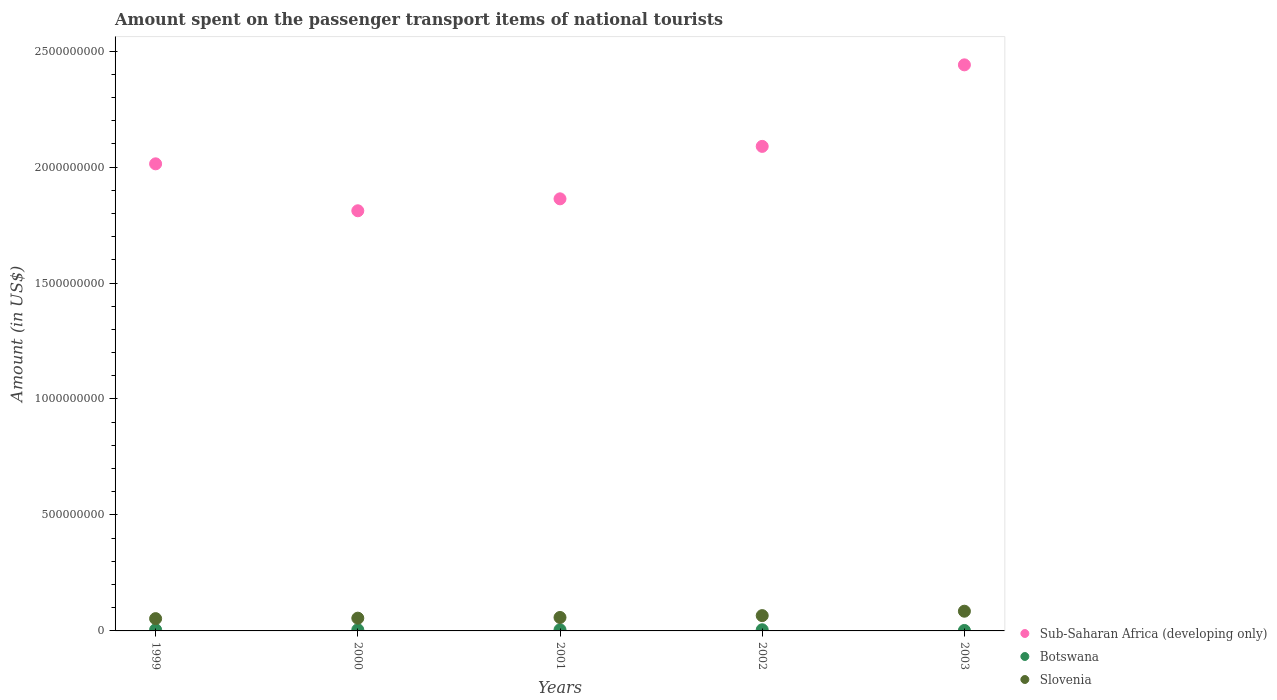How many different coloured dotlines are there?
Offer a terse response. 3. Is the number of dotlines equal to the number of legend labels?
Your response must be concise. Yes. What is the amount spent on the passenger transport items of national tourists in Botswana in 2000?
Make the answer very short. 5.00e+06. Across all years, what is the maximum amount spent on the passenger transport items of national tourists in Botswana?
Your answer should be very brief. 5.00e+06. Across all years, what is the minimum amount spent on the passenger transport items of national tourists in Botswana?
Your response must be concise. 2.00e+06. In which year was the amount spent on the passenger transport items of national tourists in Botswana minimum?
Provide a succinct answer. 2003. What is the total amount spent on the passenger transport items of national tourists in Slovenia in the graph?
Offer a terse response. 3.17e+08. What is the difference between the amount spent on the passenger transport items of national tourists in Sub-Saharan Africa (developing only) in 2000 and that in 2002?
Your answer should be very brief. -2.78e+08. What is the difference between the amount spent on the passenger transport items of national tourists in Botswana in 2003 and the amount spent on the passenger transport items of national tourists in Sub-Saharan Africa (developing only) in 2000?
Make the answer very short. -1.81e+09. What is the average amount spent on the passenger transport items of national tourists in Sub-Saharan Africa (developing only) per year?
Provide a short and direct response. 2.04e+09. In the year 2000, what is the difference between the amount spent on the passenger transport items of national tourists in Slovenia and amount spent on the passenger transport items of national tourists in Sub-Saharan Africa (developing only)?
Provide a succinct answer. -1.76e+09. What is the ratio of the amount spent on the passenger transport items of national tourists in Sub-Saharan Africa (developing only) in 2001 to that in 2002?
Your answer should be very brief. 0.89. Is the difference between the amount spent on the passenger transport items of national tourists in Slovenia in 2000 and 2002 greater than the difference between the amount spent on the passenger transport items of national tourists in Sub-Saharan Africa (developing only) in 2000 and 2002?
Your answer should be very brief. Yes. What is the difference between the highest and the second highest amount spent on the passenger transport items of national tourists in Sub-Saharan Africa (developing only)?
Offer a very short reply. 3.52e+08. What is the difference between the highest and the lowest amount spent on the passenger transport items of national tourists in Sub-Saharan Africa (developing only)?
Provide a short and direct response. 6.29e+08. In how many years, is the amount spent on the passenger transport items of national tourists in Slovenia greater than the average amount spent on the passenger transport items of national tourists in Slovenia taken over all years?
Offer a terse response. 2. Is the sum of the amount spent on the passenger transport items of national tourists in Sub-Saharan Africa (developing only) in 2000 and 2002 greater than the maximum amount spent on the passenger transport items of national tourists in Botswana across all years?
Provide a short and direct response. Yes. Is the amount spent on the passenger transport items of national tourists in Botswana strictly less than the amount spent on the passenger transport items of national tourists in Sub-Saharan Africa (developing only) over the years?
Your answer should be very brief. Yes. Are the values on the major ticks of Y-axis written in scientific E-notation?
Ensure brevity in your answer.  No. Does the graph contain any zero values?
Ensure brevity in your answer.  No. Where does the legend appear in the graph?
Offer a very short reply. Bottom right. How many legend labels are there?
Make the answer very short. 3. How are the legend labels stacked?
Your answer should be very brief. Vertical. What is the title of the graph?
Provide a short and direct response. Amount spent on the passenger transport items of national tourists. What is the label or title of the Y-axis?
Offer a very short reply. Amount (in US$). What is the Amount (in US$) in Sub-Saharan Africa (developing only) in 1999?
Give a very brief answer. 2.01e+09. What is the Amount (in US$) of Botswana in 1999?
Offer a very short reply. 5.00e+06. What is the Amount (in US$) of Slovenia in 1999?
Your answer should be very brief. 5.30e+07. What is the Amount (in US$) in Sub-Saharan Africa (developing only) in 2000?
Your answer should be very brief. 1.81e+09. What is the Amount (in US$) of Botswana in 2000?
Make the answer very short. 5.00e+06. What is the Amount (in US$) in Slovenia in 2000?
Your answer should be very brief. 5.50e+07. What is the Amount (in US$) of Sub-Saharan Africa (developing only) in 2001?
Offer a terse response. 1.86e+09. What is the Amount (in US$) of Slovenia in 2001?
Your answer should be very brief. 5.80e+07. What is the Amount (in US$) in Sub-Saharan Africa (developing only) in 2002?
Make the answer very short. 2.09e+09. What is the Amount (in US$) of Slovenia in 2002?
Keep it short and to the point. 6.60e+07. What is the Amount (in US$) in Sub-Saharan Africa (developing only) in 2003?
Make the answer very short. 2.44e+09. What is the Amount (in US$) in Slovenia in 2003?
Make the answer very short. 8.50e+07. Across all years, what is the maximum Amount (in US$) in Sub-Saharan Africa (developing only)?
Keep it short and to the point. 2.44e+09. Across all years, what is the maximum Amount (in US$) of Botswana?
Provide a short and direct response. 5.00e+06. Across all years, what is the maximum Amount (in US$) of Slovenia?
Offer a terse response. 8.50e+07. Across all years, what is the minimum Amount (in US$) in Sub-Saharan Africa (developing only)?
Your answer should be very brief. 1.81e+09. Across all years, what is the minimum Amount (in US$) in Slovenia?
Offer a very short reply. 5.30e+07. What is the total Amount (in US$) in Sub-Saharan Africa (developing only) in the graph?
Make the answer very short. 1.02e+1. What is the total Amount (in US$) of Botswana in the graph?
Your answer should be very brief. 2.20e+07. What is the total Amount (in US$) of Slovenia in the graph?
Keep it short and to the point. 3.17e+08. What is the difference between the Amount (in US$) of Sub-Saharan Africa (developing only) in 1999 and that in 2000?
Provide a succinct answer. 2.02e+08. What is the difference between the Amount (in US$) of Slovenia in 1999 and that in 2000?
Your response must be concise. -2.00e+06. What is the difference between the Amount (in US$) of Sub-Saharan Africa (developing only) in 1999 and that in 2001?
Give a very brief answer. 1.51e+08. What is the difference between the Amount (in US$) of Botswana in 1999 and that in 2001?
Provide a short and direct response. 0. What is the difference between the Amount (in US$) of Slovenia in 1999 and that in 2001?
Ensure brevity in your answer.  -5.00e+06. What is the difference between the Amount (in US$) in Sub-Saharan Africa (developing only) in 1999 and that in 2002?
Provide a short and direct response. -7.53e+07. What is the difference between the Amount (in US$) of Botswana in 1999 and that in 2002?
Keep it short and to the point. 0. What is the difference between the Amount (in US$) of Slovenia in 1999 and that in 2002?
Provide a short and direct response. -1.30e+07. What is the difference between the Amount (in US$) in Sub-Saharan Africa (developing only) in 1999 and that in 2003?
Offer a very short reply. -4.27e+08. What is the difference between the Amount (in US$) of Botswana in 1999 and that in 2003?
Offer a very short reply. 3.00e+06. What is the difference between the Amount (in US$) in Slovenia in 1999 and that in 2003?
Offer a terse response. -3.20e+07. What is the difference between the Amount (in US$) of Sub-Saharan Africa (developing only) in 2000 and that in 2001?
Offer a terse response. -5.15e+07. What is the difference between the Amount (in US$) of Slovenia in 2000 and that in 2001?
Your answer should be very brief. -3.00e+06. What is the difference between the Amount (in US$) of Sub-Saharan Africa (developing only) in 2000 and that in 2002?
Your answer should be very brief. -2.78e+08. What is the difference between the Amount (in US$) of Slovenia in 2000 and that in 2002?
Provide a short and direct response. -1.10e+07. What is the difference between the Amount (in US$) in Sub-Saharan Africa (developing only) in 2000 and that in 2003?
Provide a succinct answer. -6.29e+08. What is the difference between the Amount (in US$) of Slovenia in 2000 and that in 2003?
Keep it short and to the point. -3.00e+07. What is the difference between the Amount (in US$) in Sub-Saharan Africa (developing only) in 2001 and that in 2002?
Provide a short and direct response. -2.26e+08. What is the difference between the Amount (in US$) of Botswana in 2001 and that in 2002?
Provide a succinct answer. 0. What is the difference between the Amount (in US$) in Slovenia in 2001 and that in 2002?
Ensure brevity in your answer.  -8.00e+06. What is the difference between the Amount (in US$) of Sub-Saharan Africa (developing only) in 2001 and that in 2003?
Offer a terse response. -5.78e+08. What is the difference between the Amount (in US$) in Botswana in 2001 and that in 2003?
Provide a short and direct response. 3.00e+06. What is the difference between the Amount (in US$) in Slovenia in 2001 and that in 2003?
Your answer should be compact. -2.70e+07. What is the difference between the Amount (in US$) of Sub-Saharan Africa (developing only) in 2002 and that in 2003?
Make the answer very short. -3.52e+08. What is the difference between the Amount (in US$) of Slovenia in 2002 and that in 2003?
Your response must be concise. -1.90e+07. What is the difference between the Amount (in US$) of Sub-Saharan Africa (developing only) in 1999 and the Amount (in US$) of Botswana in 2000?
Your response must be concise. 2.01e+09. What is the difference between the Amount (in US$) of Sub-Saharan Africa (developing only) in 1999 and the Amount (in US$) of Slovenia in 2000?
Your answer should be compact. 1.96e+09. What is the difference between the Amount (in US$) in Botswana in 1999 and the Amount (in US$) in Slovenia in 2000?
Offer a terse response. -5.00e+07. What is the difference between the Amount (in US$) of Sub-Saharan Africa (developing only) in 1999 and the Amount (in US$) of Botswana in 2001?
Provide a succinct answer. 2.01e+09. What is the difference between the Amount (in US$) in Sub-Saharan Africa (developing only) in 1999 and the Amount (in US$) in Slovenia in 2001?
Your answer should be very brief. 1.96e+09. What is the difference between the Amount (in US$) in Botswana in 1999 and the Amount (in US$) in Slovenia in 2001?
Give a very brief answer. -5.30e+07. What is the difference between the Amount (in US$) in Sub-Saharan Africa (developing only) in 1999 and the Amount (in US$) in Botswana in 2002?
Make the answer very short. 2.01e+09. What is the difference between the Amount (in US$) of Sub-Saharan Africa (developing only) in 1999 and the Amount (in US$) of Slovenia in 2002?
Keep it short and to the point. 1.95e+09. What is the difference between the Amount (in US$) in Botswana in 1999 and the Amount (in US$) in Slovenia in 2002?
Offer a very short reply. -6.10e+07. What is the difference between the Amount (in US$) of Sub-Saharan Africa (developing only) in 1999 and the Amount (in US$) of Botswana in 2003?
Provide a short and direct response. 2.01e+09. What is the difference between the Amount (in US$) in Sub-Saharan Africa (developing only) in 1999 and the Amount (in US$) in Slovenia in 2003?
Provide a succinct answer. 1.93e+09. What is the difference between the Amount (in US$) of Botswana in 1999 and the Amount (in US$) of Slovenia in 2003?
Ensure brevity in your answer.  -8.00e+07. What is the difference between the Amount (in US$) of Sub-Saharan Africa (developing only) in 2000 and the Amount (in US$) of Botswana in 2001?
Keep it short and to the point. 1.81e+09. What is the difference between the Amount (in US$) of Sub-Saharan Africa (developing only) in 2000 and the Amount (in US$) of Slovenia in 2001?
Your response must be concise. 1.75e+09. What is the difference between the Amount (in US$) of Botswana in 2000 and the Amount (in US$) of Slovenia in 2001?
Give a very brief answer. -5.30e+07. What is the difference between the Amount (in US$) in Sub-Saharan Africa (developing only) in 2000 and the Amount (in US$) in Botswana in 2002?
Provide a succinct answer. 1.81e+09. What is the difference between the Amount (in US$) in Sub-Saharan Africa (developing only) in 2000 and the Amount (in US$) in Slovenia in 2002?
Your response must be concise. 1.75e+09. What is the difference between the Amount (in US$) of Botswana in 2000 and the Amount (in US$) of Slovenia in 2002?
Your answer should be very brief. -6.10e+07. What is the difference between the Amount (in US$) of Sub-Saharan Africa (developing only) in 2000 and the Amount (in US$) of Botswana in 2003?
Your response must be concise. 1.81e+09. What is the difference between the Amount (in US$) of Sub-Saharan Africa (developing only) in 2000 and the Amount (in US$) of Slovenia in 2003?
Make the answer very short. 1.73e+09. What is the difference between the Amount (in US$) of Botswana in 2000 and the Amount (in US$) of Slovenia in 2003?
Ensure brevity in your answer.  -8.00e+07. What is the difference between the Amount (in US$) in Sub-Saharan Africa (developing only) in 2001 and the Amount (in US$) in Botswana in 2002?
Ensure brevity in your answer.  1.86e+09. What is the difference between the Amount (in US$) in Sub-Saharan Africa (developing only) in 2001 and the Amount (in US$) in Slovenia in 2002?
Give a very brief answer. 1.80e+09. What is the difference between the Amount (in US$) of Botswana in 2001 and the Amount (in US$) of Slovenia in 2002?
Offer a very short reply. -6.10e+07. What is the difference between the Amount (in US$) in Sub-Saharan Africa (developing only) in 2001 and the Amount (in US$) in Botswana in 2003?
Offer a terse response. 1.86e+09. What is the difference between the Amount (in US$) of Sub-Saharan Africa (developing only) in 2001 and the Amount (in US$) of Slovenia in 2003?
Offer a terse response. 1.78e+09. What is the difference between the Amount (in US$) of Botswana in 2001 and the Amount (in US$) of Slovenia in 2003?
Your response must be concise. -8.00e+07. What is the difference between the Amount (in US$) in Sub-Saharan Africa (developing only) in 2002 and the Amount (in US$) in Botswana in 2003?
Your answer should be compact. 2.09e+09. What is the difference between the Amount (in US$) of Sub-Saharan Africa (developing only) in 2002 and the Amount (in US$) of Slovenia in 2003?
Ensure brevity in your answer.  2.00e+09. What is the difference between the Amount (in US$) in Botswana in 2002 and the Amount (in US$) in Slovenia in 2003?
Offer a very short reply. -8.00e+07. What is the average Amount (in US$) in Sub-Saharan Africa (developing only) per year?
Your response must be concise. 2.04e+09. What is the average Amount (in US$) of Botswana per year?
Keep it short and to the point. 4.40e+06. What is the average Amount (in US$) of Slovenia per year?
Provide a succinct answer. 6.34e+07. In the year 1999, what is the difference between the Amount (in US$) of Sub-Saharan Africa (developing only) and Amount (in US$) of Botswana?
Your answer should be compact. 2.01e+09. In the year 1999, what is the difference between the Amount (in US$) in Sub-Saharan Africa (developing only) and Amount (in US$) in Slovenia?
Keep it short and to the point. 1.96e+09. In the year 1999, what is the difference between the Amount (in US$) of Botswana and Amount (in US$) of Slovenia?
Offer a very short reply. -4.80e+07. In the year 2000, what is the difference between the Amount (in US$) of Sub-Saharan Africa (developing only) and Amount (in US$) of Botswana?
Keep it short and to the point. 1.81e+09. In the year 2000, what is the difference between the Amount (in US$) in Sub-Saharan Africa (developing only) and Amount (in US$) in Slovenia?
Make the answer very short. 1.76e+09. In the year 2000, what is the difference between the Amount (in US$) of Botswana and Amount (in US$) of Slovenia?
Your response must be concise. -5.00e+07. In the year 2001, what is the difference between the Amount (in US$) of Sub-Saharan Africa (developing only) and Amount (in US$) of Botswana?
Offer a terse response. 1.86e+09. In the year 2001, what is the difference between the Amount (in US$) of Sub-Saharan Africa (developing only) and Amount (in US$) of Slovenia?
Offer a very short reply. 1.80e+09. In the year 2001, what is the difference between the Amount (in US$) in Botswana and Amount (in US$) in Slovenia?
Give a very brief answer. -5.30e+07. In the year 2002, what is the difference between the Amount (in US$) in Sub-Saharan Africa (developing only) and Amount (in US$) in Botswana?
Offer a terse response. 2.08e+09. In the year 2002, what is the difference between the Amount (in US$) of Sub-Saharan Africa (developing only) and Amount (in US$) of Slovenia?
Your response must be concise. 2.02e+09. In the year 2002, what is the difference between the Amount (in US$) of Botswana and Amount (in US$) of Slovenia?
Your response must be concise. -6.10e+07. In the year 2003, what is the difference between the Amount (in US$) in Sub-Saharan Africa (developing only) and Amount (in US$) in Botswana?
Keep it short and to the point. 2.44e+09. In the year 2003, what is the difference between the Amount (in US$) of Sub-Saharan Africa (developing only) and Amount (in US$) of Slovenia?
Your answer should be very brief. 2.36e+09. In the year 2003, what is the difference between the Amount (in US$) of Botswana and Amount (in US$) of Slovenia?
Offer a very short reply. -8.30e+07. What is the ratio of the Amount (in US$) of Sub-Saharan Africa (developing only) in 1999 to that in 2000?
Keep it short and to the point. 1.11. What is the ratio of the Amount (in US$) in Slovenia in 1999 to that in 2000?
Provide a short and direct response. 0.96. What is the ratio of the Amount (in US$) in Sub-Saharan Africa (developing only) in 1999 to that in 2001?
Offer a terse response. 1.08. What is the ratio of the Amount (in US$) in Slovenia in 1999 to that in 2001?
Provide a succinct answer. 0.91. What is the ratio of the Amount (in US$) of Slovenia in 1999 to that in 2002?
Your response must be concise. 0.8. What is the ratio of the Amount (in US$) of Sub-Saharan Africa (developing only) in 1999 to that in 2003?
Keep it short and to the point. 0.83. What is the ratio of the Amount (in US$) of Botswana in 1999 to that in 2003?
Your answer should be very brief. 2.5. What is the ratio of the Amount (in US$) in Slovenia in 1999 to that in 2003?
Offer a terse response. 0.62. What is the ratio of the Amount (in US$) in Sub-Saharan Africa (developing only) in 2000 to that in 2001?
Your answer should be compact. 0.97. What is the ratio of the Amount (in US$) in Slovenia in 2000 to that in 2001?
Ensure brevity in your answer.  0.95. What is the ratio of the Amount (in US$) of Sub-Saharan Africa (developing only) in 2000 to that in 2002?
Your answer should be compact. 0.87. What is the ratio of the Amount (in US$) in Sub-Saharan Africa (developing only) in 2000 to that in 2003?
Your response must be concise. 0.74. What is the ratio of the Amount (in US$) of Slovenia in 2000 to that in 2003?
Keep it short and to the point. 0.65. What is the ratio of the Amount (in US$) in Sub-Saharan Africa (developing only) in 2001 to that in 2002?
Ensure brevity in your answer.  0.89. What is the ratio of the Amount (in US$) of Botswana in 2001 to that in 2002?
Offer a terse response. 1. What is the ratio of the Amount (in US$) in Slovenia in 2001 to that in 2002?
Give a very brief answer. 0.88. What is the ratio of the Amount (in US$) of Sub-Saharan Africa (developing only) in 2001 to that in 2003?
Ensure brevity in your answer.  0.76. What is the ratio of the Amount (in US$) in Slovenia in 2001 to that in 2003?
Provide a succinct answer. 0.68. What is the ratio of the Amount (in US$) of Sub-Saharan Africa (developing only) in 2002 to that in 2003?
Offer a very short reply. 0.86. What is the ratio of the Amount (in US$) of Slovenia in 2002 to that in 2003?
Make the answer very short. 0.78. What is the difference between the highest and the second highest Amount (in US$) in Sub-Saharan Africa (developing only)?
Provide a succinct answer. 3.52e+08. What is the difference between the highest and the second highest Amount (in US$) in Slovenia?
Provide a short and direct response. 1.90e+07. What is the difference between the highest and the lowest Amount (in US$) in Sub-Saharan Africa (developing only)?
Offer a terse response. 6.29e+08. What is the difference between the highest and the lowest Amount (in US$) of Botswana?
Provide a short and direct response. 3.00e+06. What is the difference between the highest and the lowest Amount (in US$) of Slovenia?
Provide a short and direct response. 3.20e+07. 